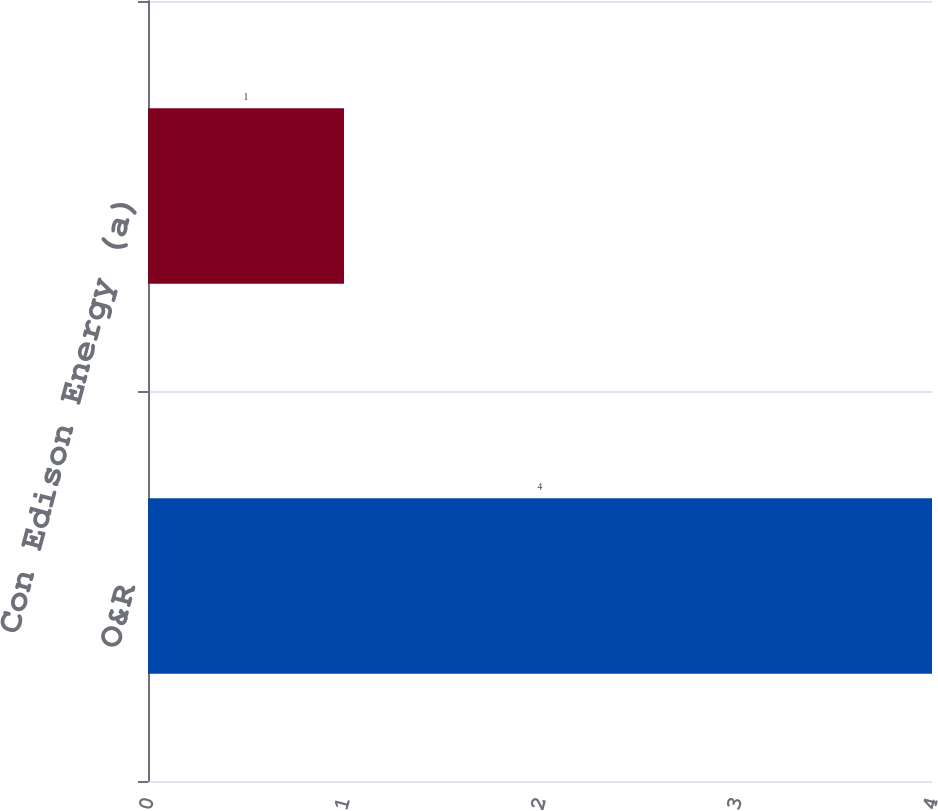Convert chart to OTSL. <chart><loc_0><loc_0><loc_500><loc_500><bar_chart><fcel>O&R<fcel>Con Edison Energy (a)<nl><fcel>4<fcel>1<nl></chart> 